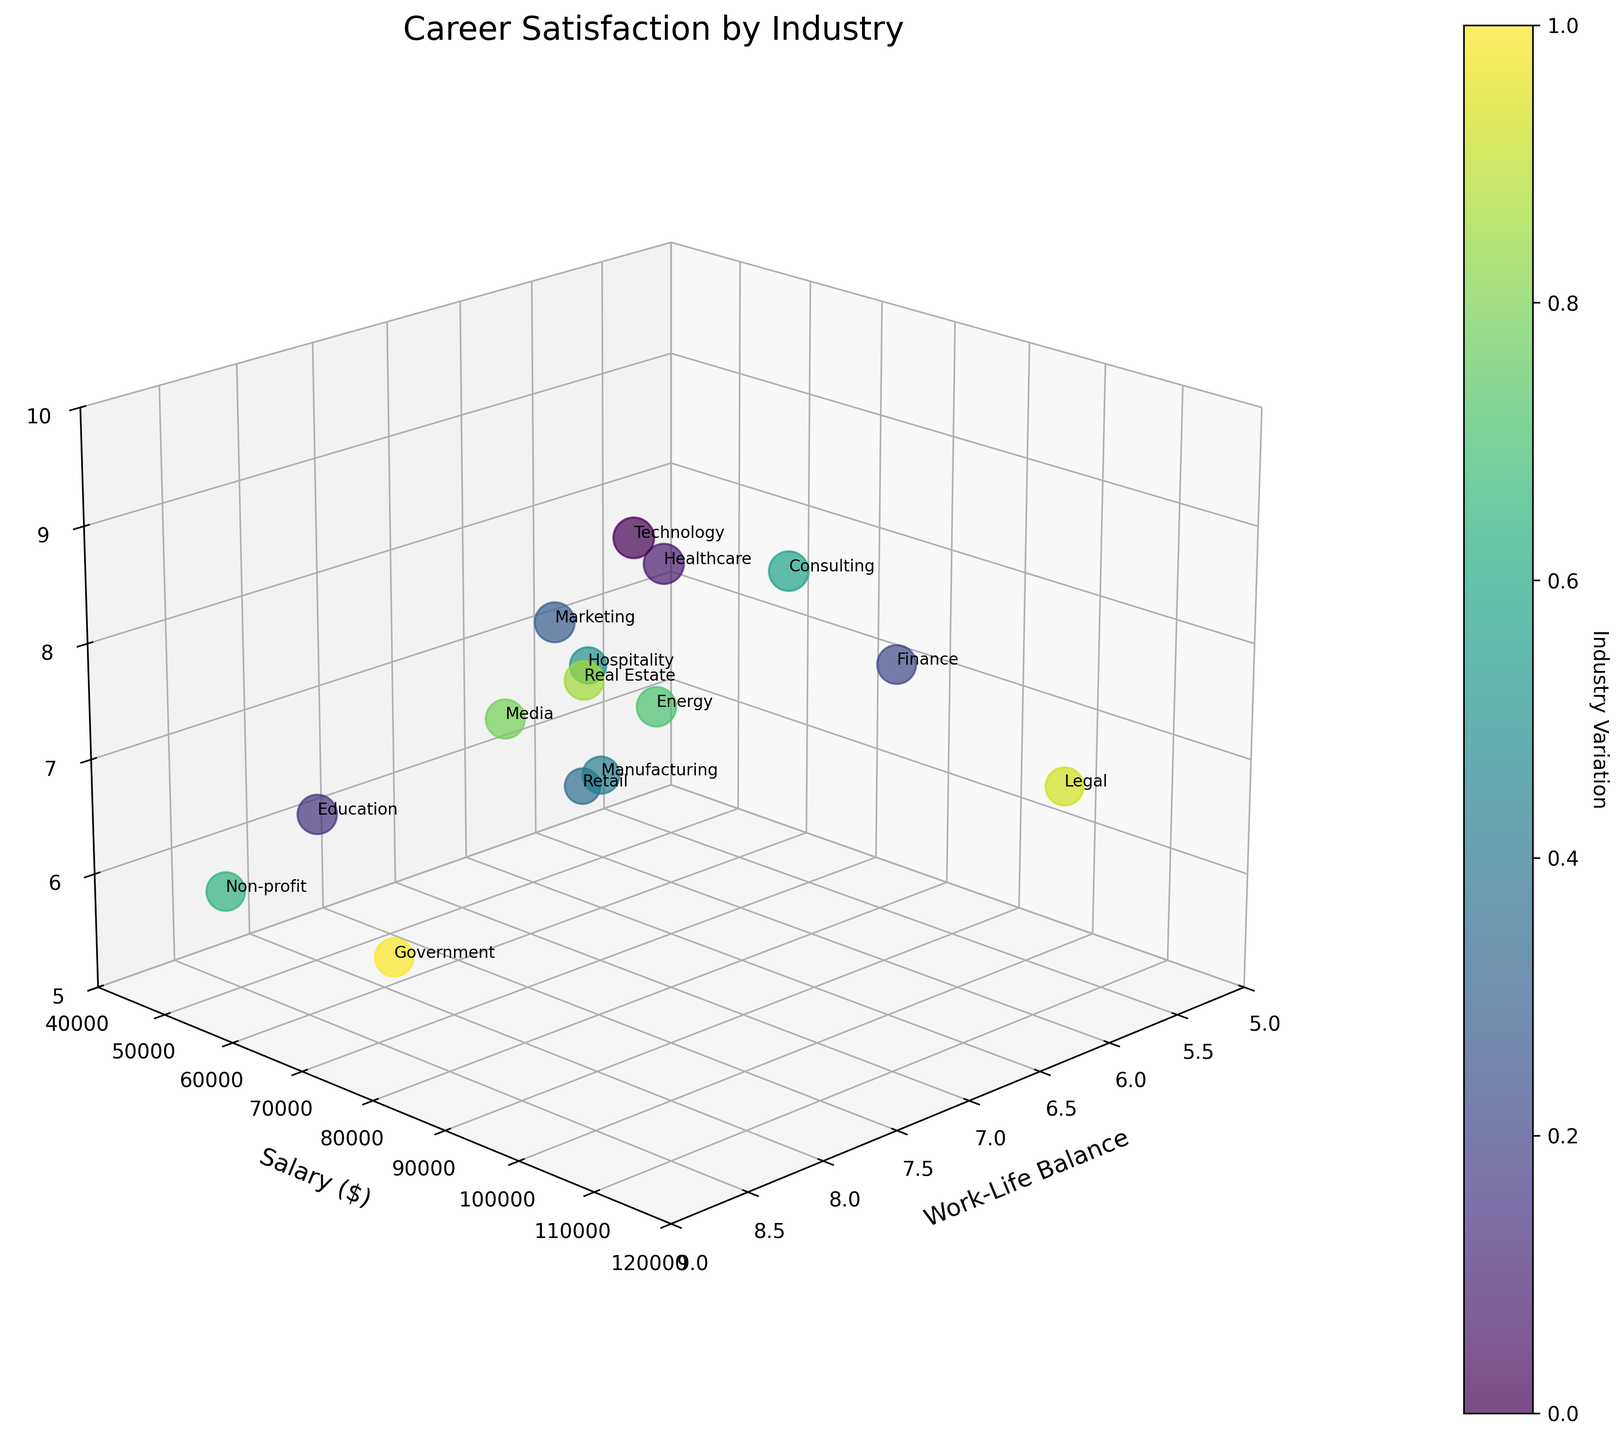What industry has the highest career satisfaction? Identify the bubble with the largest size, as the size corresponds to career satisfaction. The Non-profit industry bubble is the largest.
Answer: Non-profit What is the lowest work-life balance rating observed and for which industry? Find the bubble with the lowest x-axis value (work-life balance). The Legal industry has the lowest work-life balance at 5.8.
Answer: Legal Which industry offers the highest salary? Look for the bubble positioned highest on the y-axis (Salary). The Legal industry offers the highest salary at 110000.
Answer: Legal How many industries have a work-life balance rating above 7? Count all bubbles with x-axis values greater than 7. This applies to Technology, Education, Marketing, Media, Real Estate, Government, and Non-profit industries.
Answer: 7 Which industry has a combination of high job growth potential and low career satisfaction? Identify bubbles with high z-axis values (Job Growth Potential) and relatively smaller sizes (Career Satisfaction). The Legal industry shows high job growth potential (6.9) but lower career satisfaction (7.1).
Answer: Legal For the industry with decent work-life balance (around 7.0) but low salary (~$60,000), what are the job growth potential and career satisfaction levels? Locate the bubble near x = 7 and y = 60,000. Manufacturing, with work-life balance 6.5 and salary $60,000, has job growth potential 6.2 and career satisfaction 6.8.
Answer: Job growth potential: 6.2, Career satisfaction: 6.8 Which industry has a job growth potential close to 8.0 and what is its career satisfaction? Find bubbles with values near 8 on the z-axis. Marketing industry has job growth potential of 8.1 and career satisfaction of 7.8.
Answer: Marketing, career satisfaction: 7.8 How does the salary of the Technology industry compare to that of the Healthcare industry? Locate bubbles for these industries and compare their positions on the y-axis. The Technology industry (85000) has a higher salary than the Healthcare industry (75000).
Answer: Technology has a higher salary What industries have job growth potential but pay less than $70,000? Identify bubbles with z-axis values (Job Growth Potential) > 6 and y-axis values (Salary) < 70,000. Education (6.5, 55,000), Hospitality (6.8, 50,000), and Non-profit (5.8, 48,000) meet these criteria.
Answer: Education, Hospitality, Non-profit Which industry offers a work-life balance greater than 8 but has job growth potential less than 6? Locate bubbles with x-axis values > 8 and z-axis values < 6. Government (8.3 work-life balance, 5.6 job growth potential) meets the criteria.
Answer: Government 